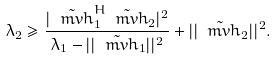<formula> <loc_0><loc_0><loc_500><loc_500>\lambda _ { 2 } \geq \frac { | \tilde { \ m v { h } } _ { 1 } ^ { H } \tilde { \ m v { h } } _ { 2 } | ^ { 2 } } { \lambda _ { 1 } - | | \tilde { \ m v { h } } _ { 1 } | | ^ { 2 } } + | | \tilde { \ m v { h } } _ { 2 } | | ^ { 2 } .</formula> 